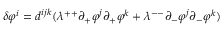<formula> <loc_0><loc_0><loc_500><loc_500>\delta \varphi ^ { i } = d ^ { i j k } ( \lambda ^ { + + } \partial _ { + } \varphi ^ { j } \partial _ { + } \varphi ^ { k } + \lambda ^ { - - } \partial _ { - } \varphi ^ { j } \partial _ { - } \varphi ^ { k } )</formula> 